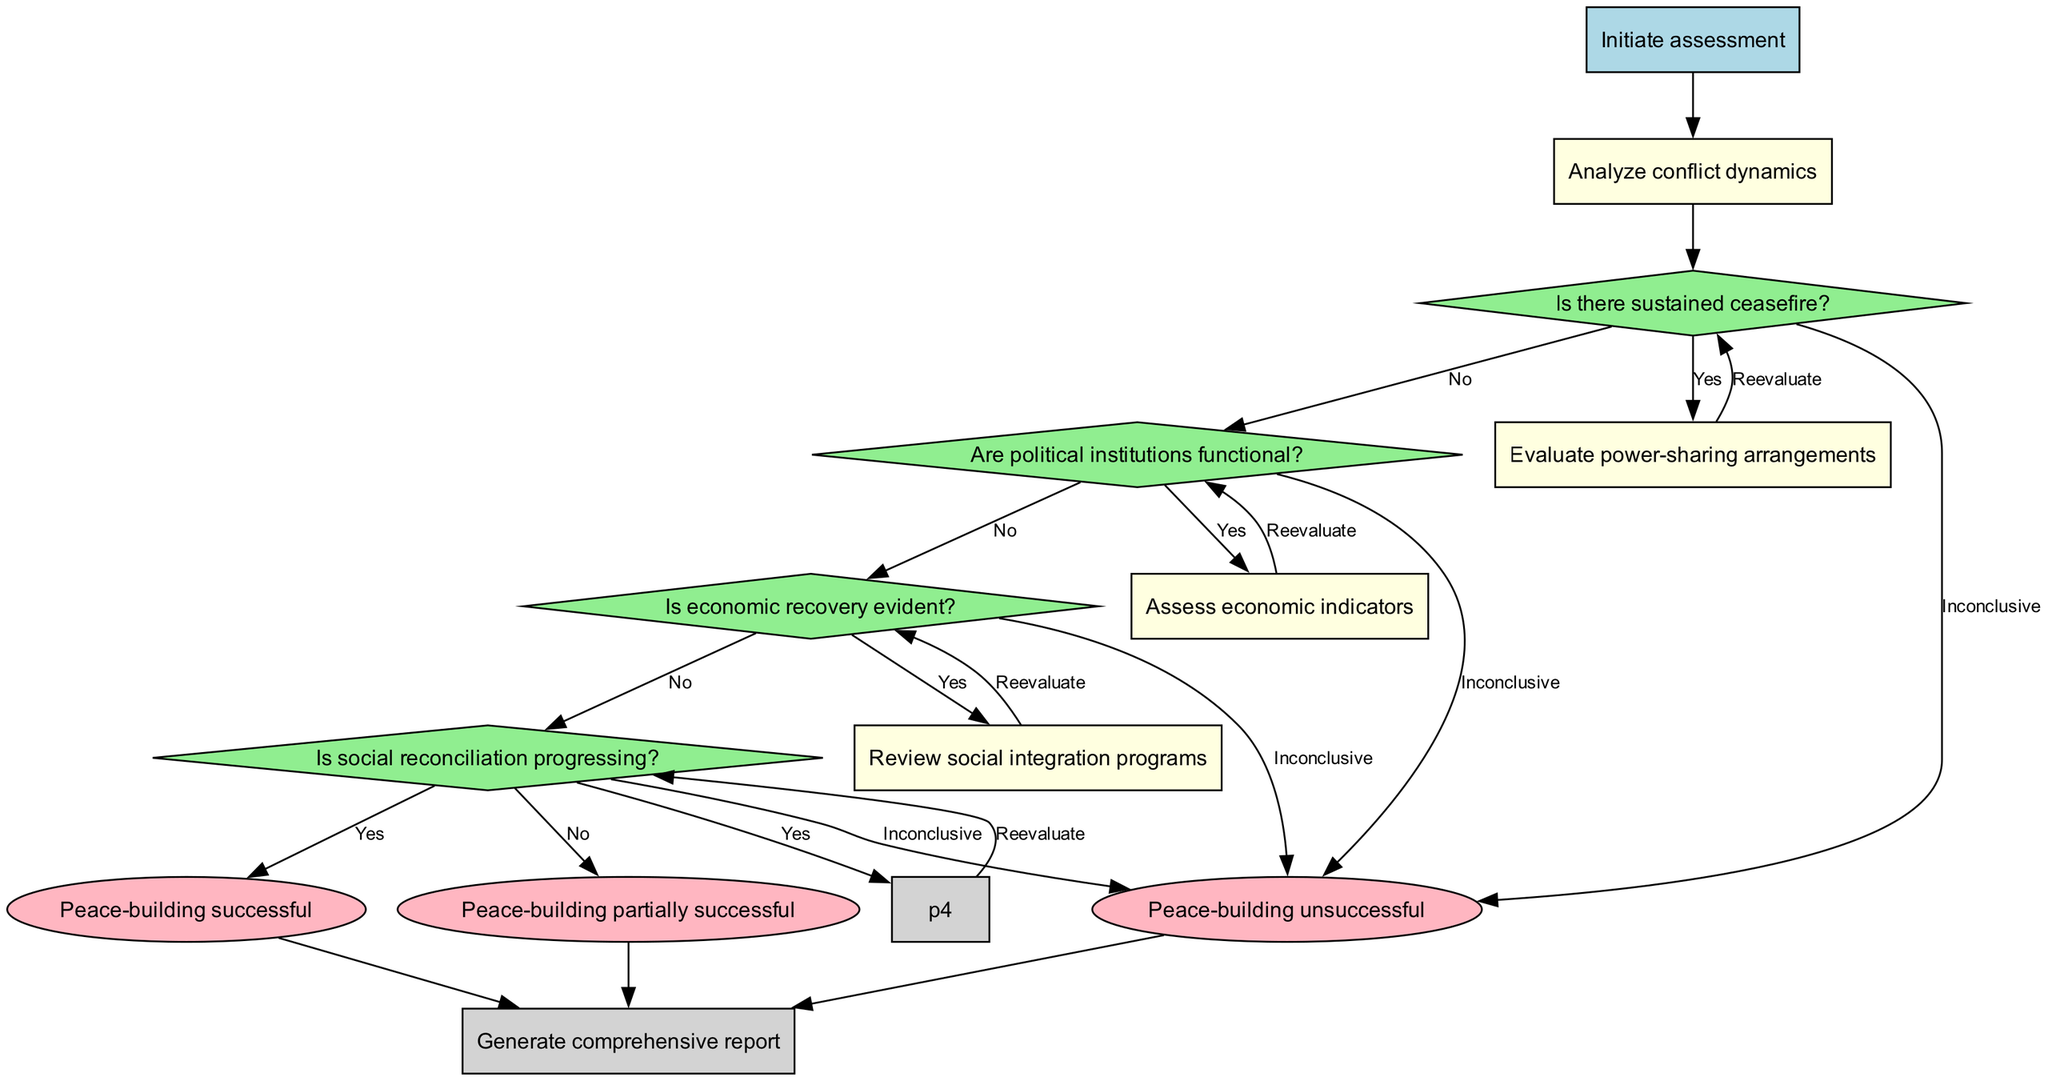What is the starting node of the diagram? The diagram indicates the starting point is labeled 'Initiate assessment'. This is directly observed as the initial node connected to the edges leading into the decision nodes.
Answer: Initiate assessment How many decision nodes are there in total? The diagram includes four decision nodes: 'Is there sustained ceasefire?', 'Are political institutions functional?', 'Is economic recovery evident?', and 'Is social reconciliation progressing?'. Counting these nodes gives a total of four.
Answer: 4 What happens if the assessment of social reconciliation progresses is inconclusive? If the assessment of social reconciliation is inconclusive, the flowchart indicates three potential output nodes: 'Peace-building unsuccessful', which is reached if any preceding decision nodes indicate 'No', and the other decision nodes also give 'Inconclusive', leading to this same output node.
Answer: Peace-building unsuccessful If the economic recovery is assessed as positive, which process node follows next? The diagram specifies that if the decision for economic recovery is met with a 'Yes', it leads back to evaluating the next criterion again via the edge leading to the subsequent decision nodes.
Answer: Review social integration programs What is the end node of the flowchart? The flowchart concludes with the end node labeled 'Generate comprehensive report'. This node is where all paths eventually lead after decisions and processes are completed.
Answer: Generate comprehensive report What does a 'No' decision in any of the criteria ultimately contribute to? A 'No' decision seen within any of the decision nodes subsequently contributes to the output nodes via 'Inconclusive' outputs or can lead to 'Reevaluate strategy' for further review of the peace-building initiative.
Answer: Reevaluate strategy Which output node corresponds to a successful peace-building initiative? The output of 'Peace-building successful' directly correlates to a positive assessment across all decision nodes particularly when 'Yes' is indicated for each criterion assessed.
Answer: Peace-building successful 